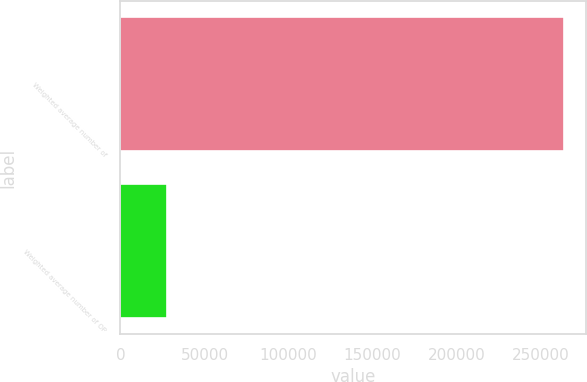<chart> <loc_0><loc_0><loc_500><loc_500><bar_chart><fcel>Weighted average number of<fcel>Weighted average number of OP<nl><fcel>263813<fcel>27998.3<nl></chart> 